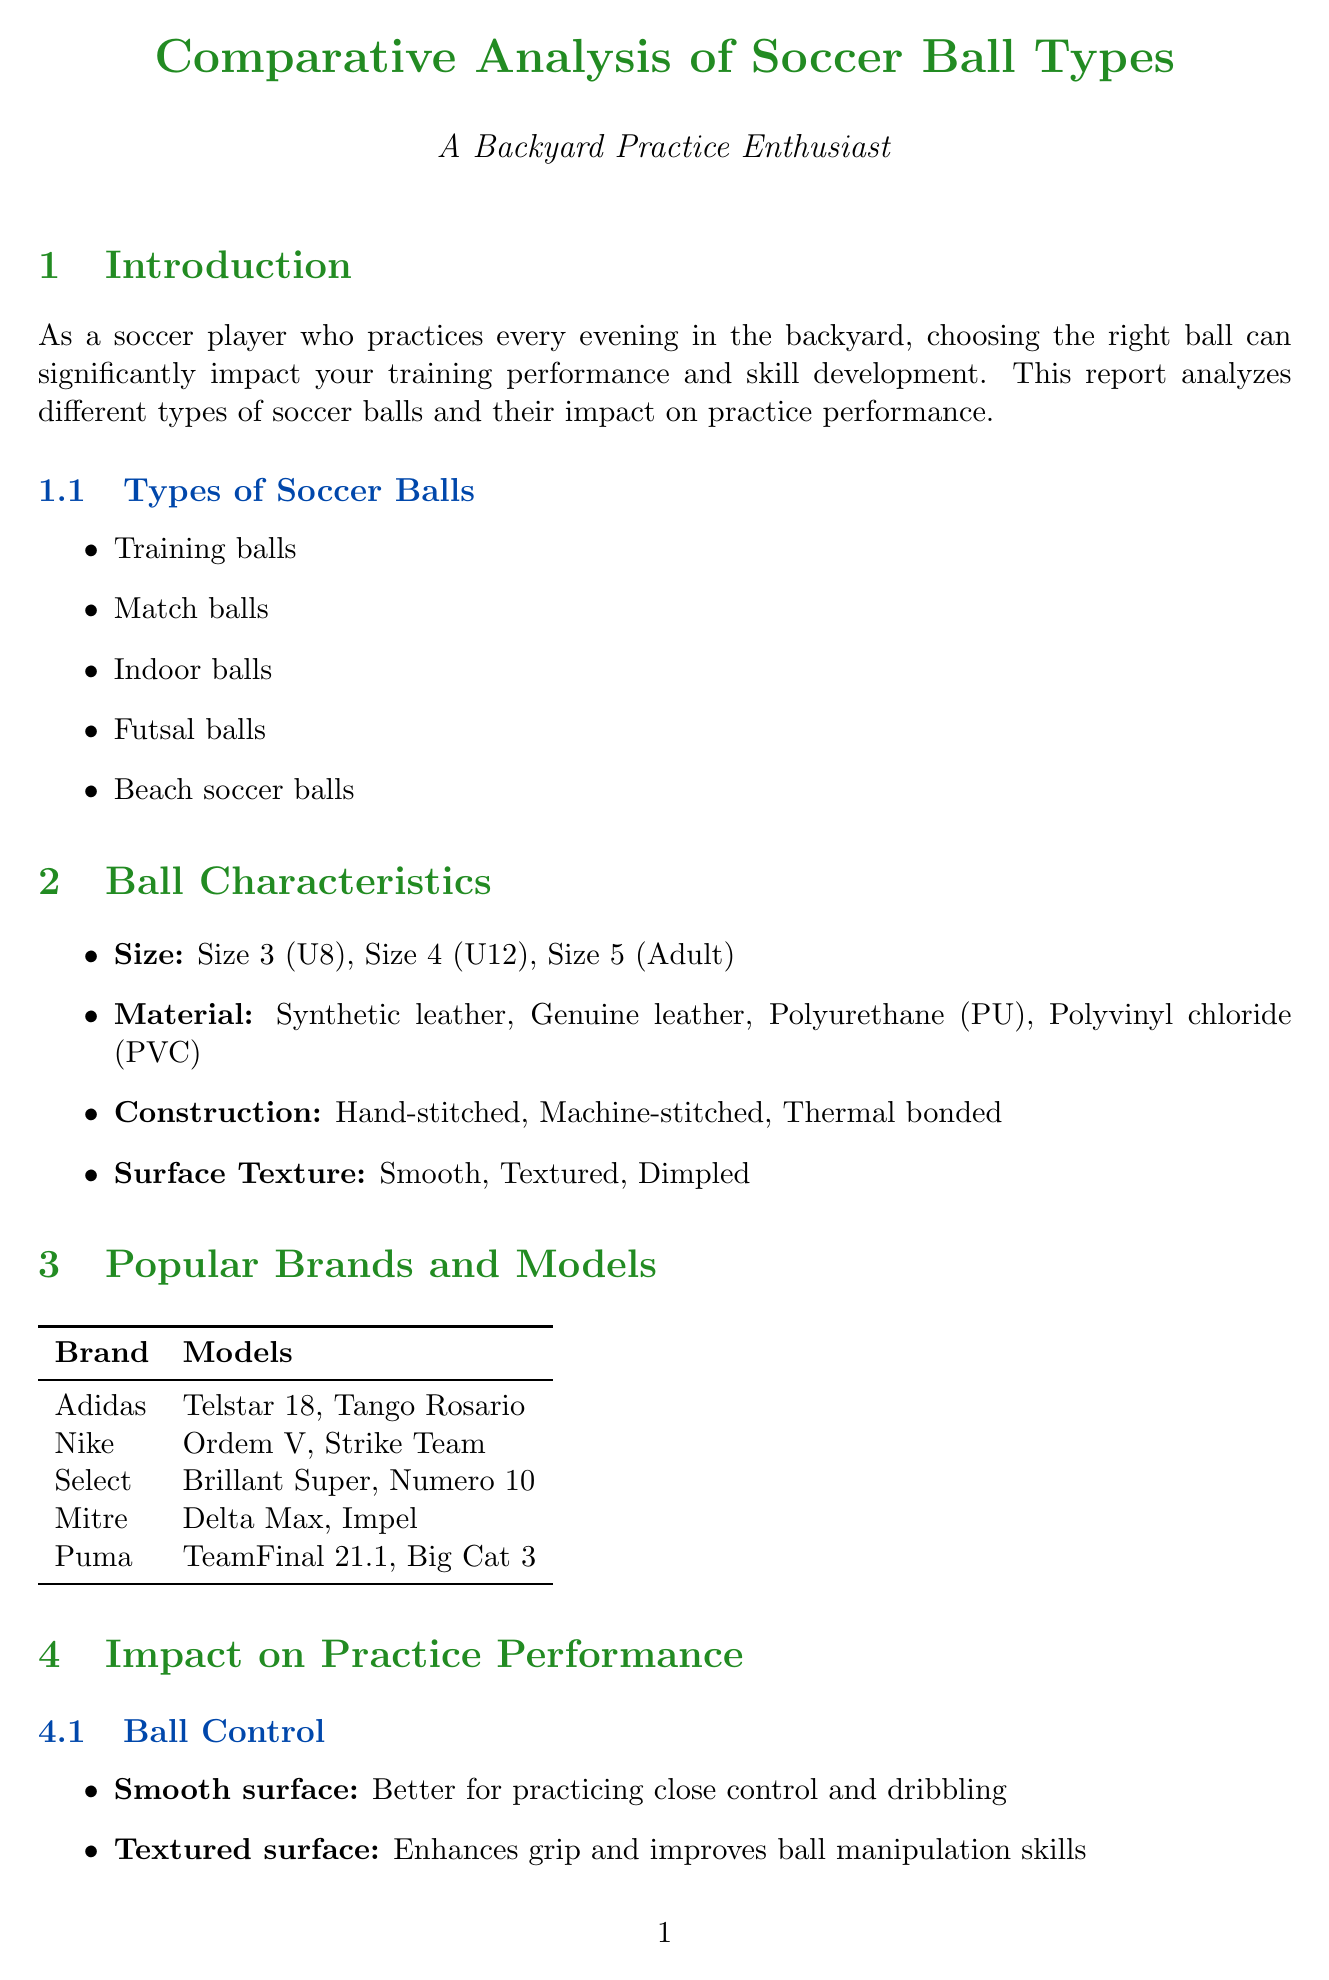What are the types of soccer balls mentioned? The document lists five types of soccer balls: Training balls, Match balls, Indoor balls, Futsal balls, Beach soccer balls.
Answer: Training balls, Match balls, Indoor balls, Futsal balls, Beach soccer balls Which brand offers the "Ordem V" model? The "Ordem V" model is listed under the Nike brand in the document.
Answer: Nike What is the price range for budget-friendly soccer balls? The document specifies a price range of $10 - $30 for budget-friendly soccer balls.
Answer: $10 - $30 What characteristic does a textured surface enhance? The document states that a textured surface enhances grip and improves ball manipulation skills.
Answer: Grip and improves ball manipulation skills Which factor should be considered for frequent backyard use? The document suggests considering durability for frequent backyard use when selecting a soccer ball.
Answer: Durability What is the main benefit of using varied ball types in practice? The document mentions that using different balls helps adapt to various game situations, highlighting the importance of varied ball types.
Answer: Adapt to various game situations What maintenance tip is provided regarding ball storage? The document advises to store the ball in a cool, dry place away from direct sunlight as part of maintenance tips.
Answer: Store in a cool, dry place away from direct sunlight What type of ball is more durable for repeated shots? The document identifies training balls as more durable for repeated shots but notes they may lack an authentic feel.
Answer: Training balls 